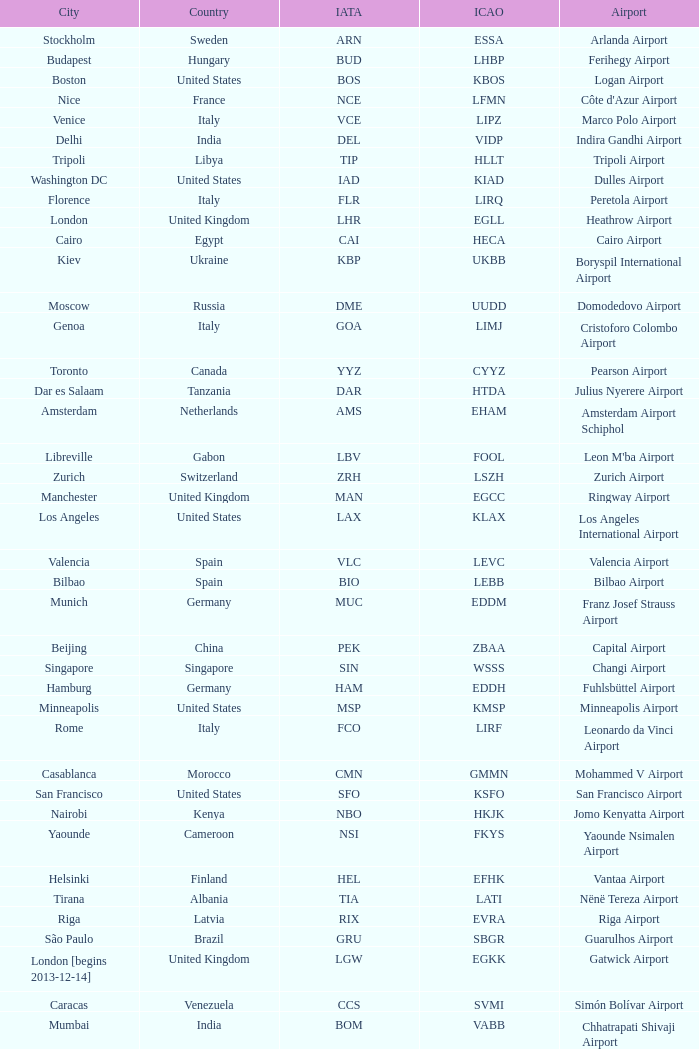What is the ICAO of Douala city? FKKD. 